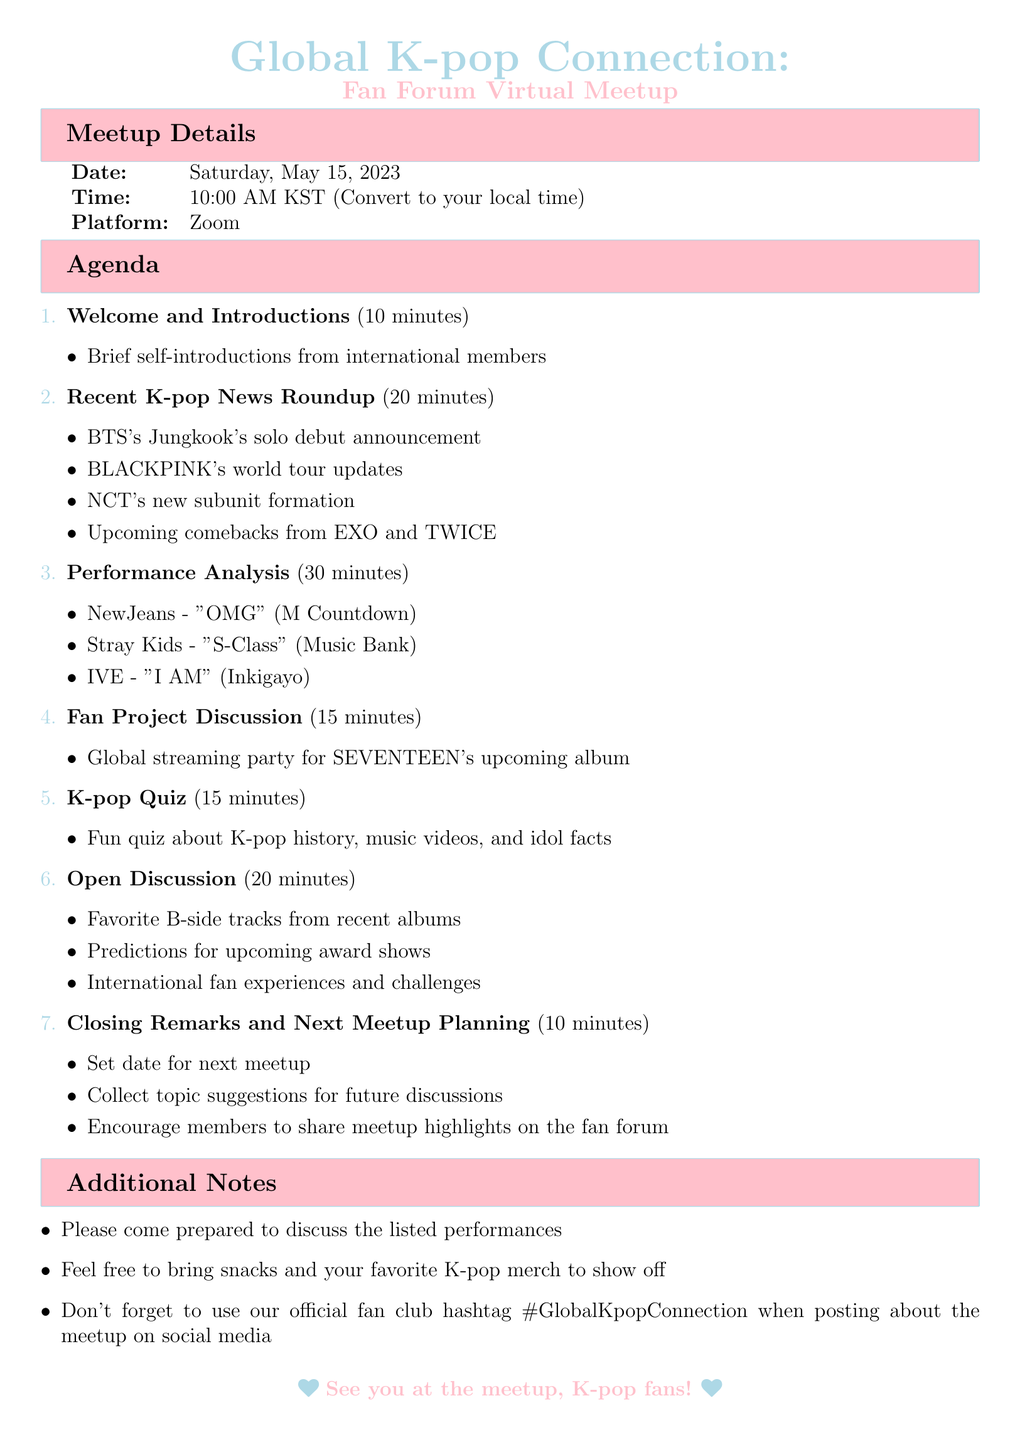What is the title of the meetup? The title of the meetup is mentioned at the beginning of the document.
Answer: Global K-pop Connection: Fan Forum Virtual Meetup What date is the virtual meetup scheduled for? The date of the meetup is explicitly stated in the document.
Answer: Saturday, May 15, 2023 How long is the "Performance Analysis" session? The duration of the "Performance Analysis" session is specified in the agenda.
Answer: 30 minutes Which platform will be used for the meetup? The platform for the meetup is listed under the meetup details.
Answer: Zoom What project will be discussed in the Fan Project Discussion? The specific fan project being discussed is detailed in the agenda section.
Answer: Global streaming party for SEVENTEEN's upcoming album How many minutes is allocated for the "Open Discussion"? The duration for the "Open Discussion" is mentioned alongside the agenda item.
Answer: 20 minutes What social media hashtag should members use when posting about the meetup? The hashtag is included in the additional notes section of the document.
Answer: #GlobalKpopConnection Which K-pop group is associated with the song "S-Class"? The song and its associated K-pop group are listed in the Performance Analysis section.
Answer: Stray Kids What is the duration of the "K-pop Quiz" section? The time allocated for the K-pop Quiz is specified in the agenda.
Answer: 15 minutes 